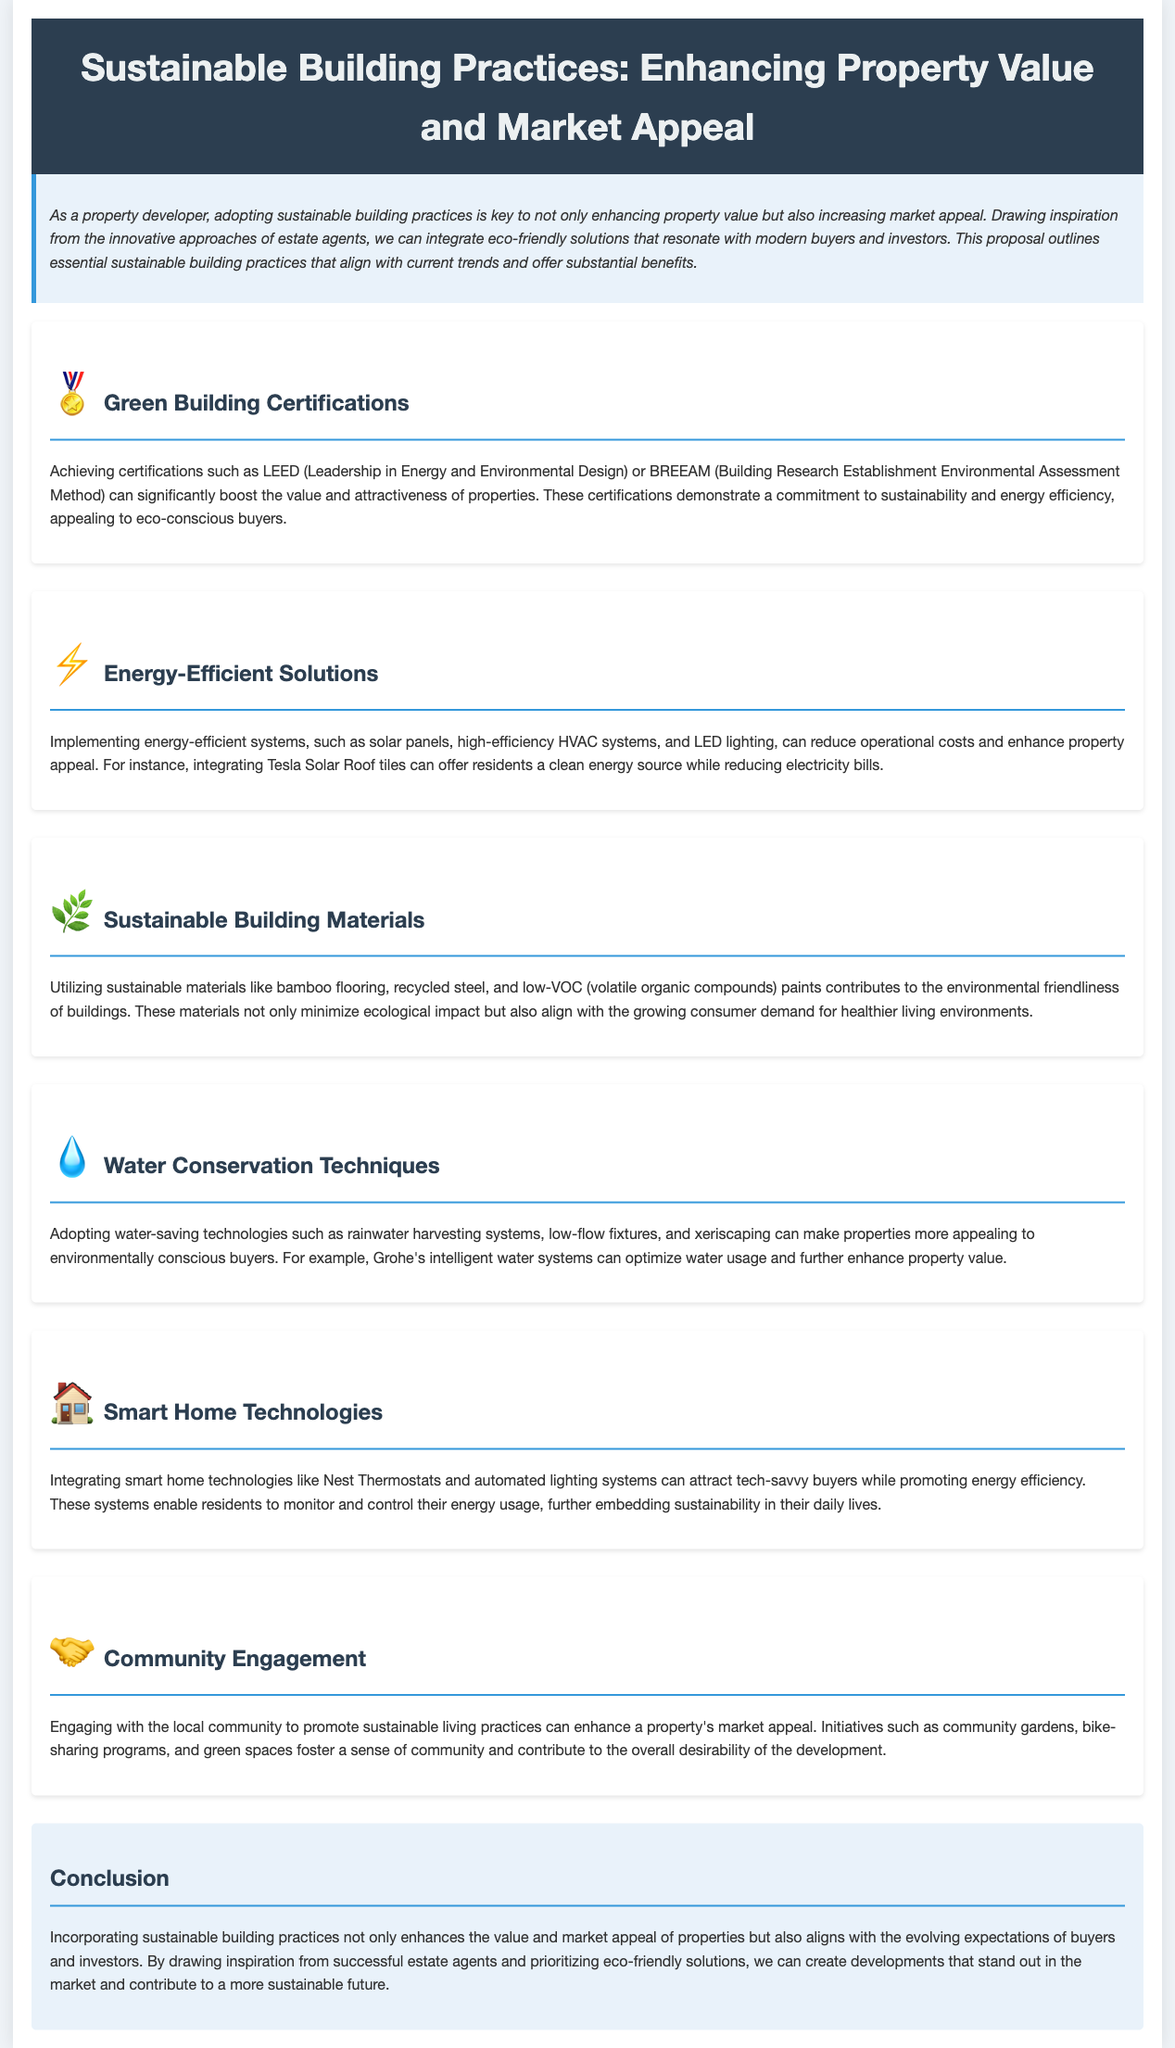What is the title of the proposal? The title is clearly stated at the beginning of the document.
Answer: Sustainable Building Practices: Enhancing Property Value and Market Appeal What certification is mentioned for enhancing property value? The document discusses specific certifications that can increase property appeal.
Answer: LEED Which energy-efficient solution is highlighted as a product example? The proposal provides an example of a specific product that is energy-efficient.
Answer: Tesla Solar Roof tiles What type of building materials does the proposal recommend? The document lists specific categories of materials that contribute to sustainability.
Answer: Sustainable materials What technology is suggested for water conservation? The document names specific technologies aimed at conserving water resources.
Answer: Rainwater harvesting systems How does community engagement contribute to property appeal? The proposal explains the benefits of certain community initiatives on market appeal.
Answer: Sense of community What is the main benefit of incorporating sustainable practices according to the conclusion? The conclusion summarizes the key advantages of adopting sustainable practices.
Answer: Enhances value Which smart home technology is mentioned in the document? The proposal lists a specific type of technology to attract buyers.
Answer: Nest Thermostats 